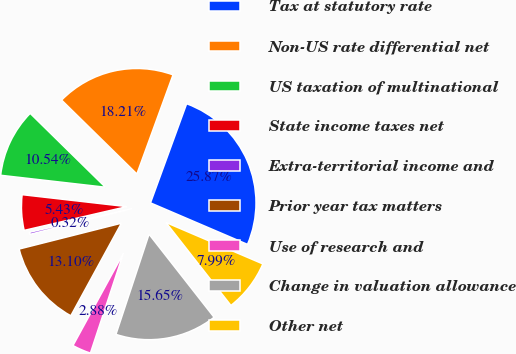Convert chart. <chart><loc_0><loc_0><loc_500><loc_500><pie_chart><fcel>Tax at statutory rate<fcel>Non-US rate differential net<fcel>US taxation of multinational<fcel>State income taxes net<fcel>Extra-territorial income and<fcel>Prior year tax matters<fcel>Use of research and<fcel>Change in valuation allowance<fcel>Other net<nl><fcel>25.87%<fcel>18.21%<fcel>10.54%<fcel>5.43%<fcel>0.32%<fcel>13.1%<fcel>2.88%<fcel>15.65%<fcel>7.99%<nl></chart> 